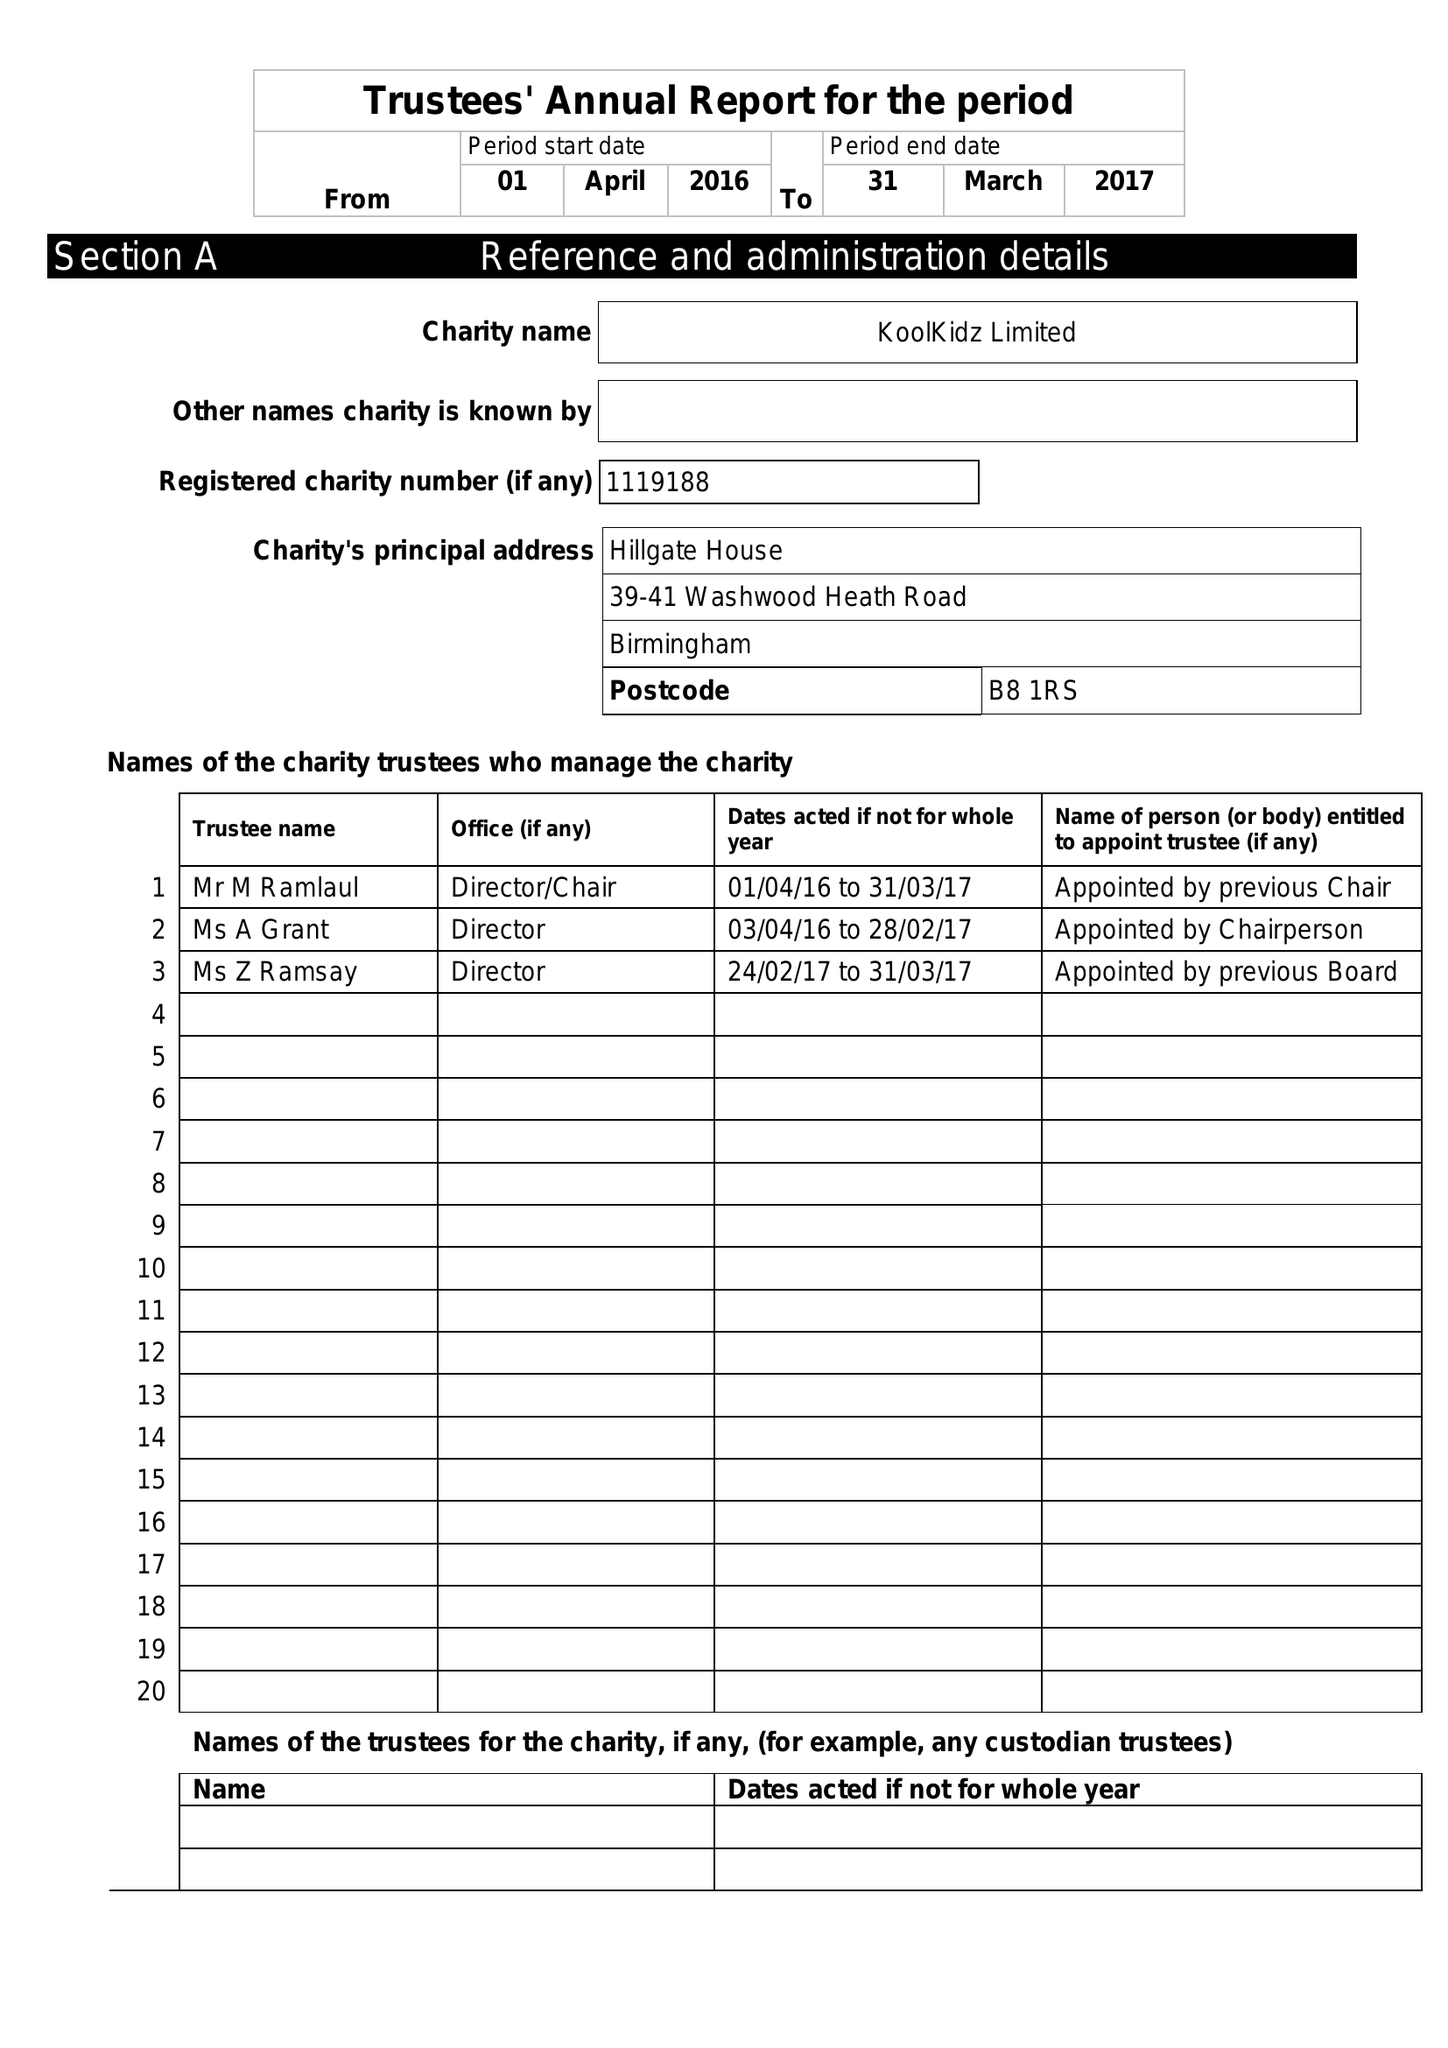What is the value for the report_date?
Answer the question using a single word or phrase. 2017-03-31 